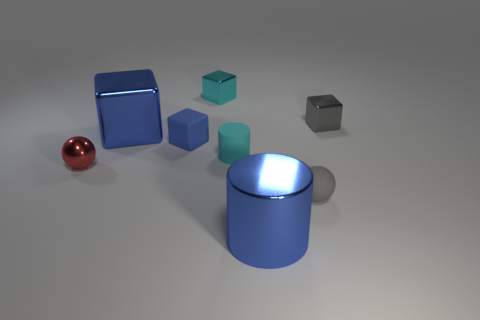How would you describe the atmosphere of this image? The image conveys a clean, minimalist atmosphere with its uncluttered composition and neutral background. The cool tones of the objects and the soft shadows contribute to a calm and orderly visual aesthetic. 